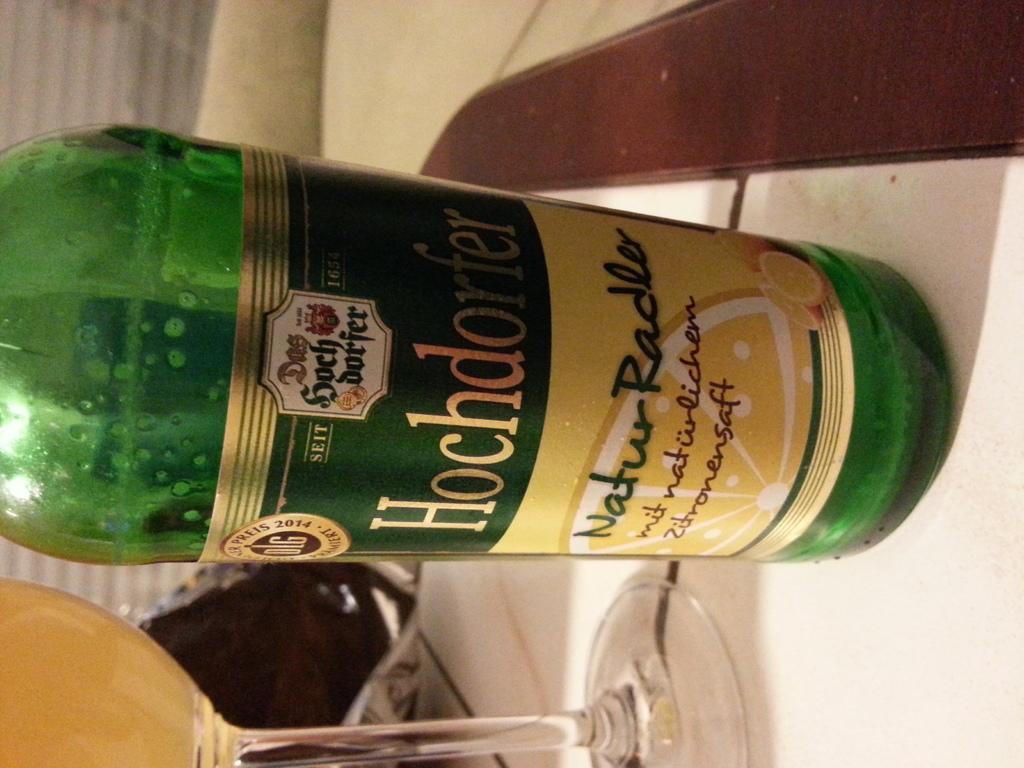How would you summarize this image in a sentence or two? In the picture we can see a bottle which is green in color and a sticker on it and written HOCHDORFER, beside the bottle we can see a glass of wine and it is placed on the table. 